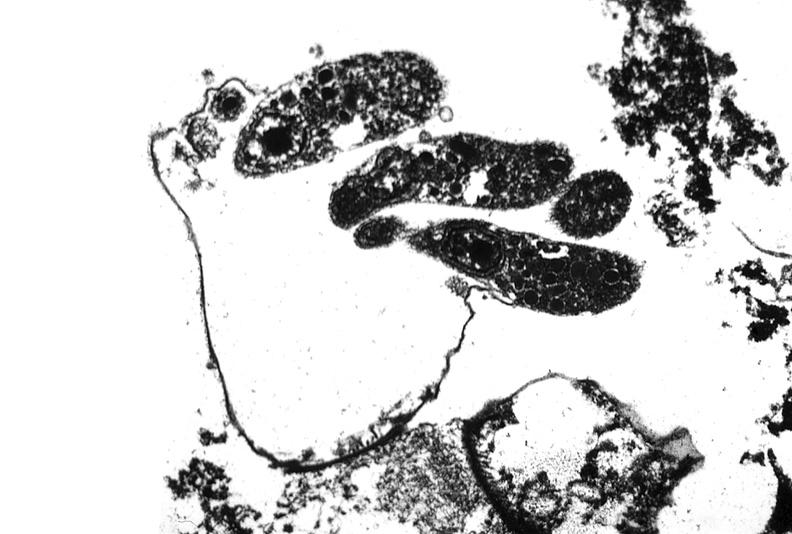what is present?
Answer the question using a single word or phrase. Gastrointestinal 